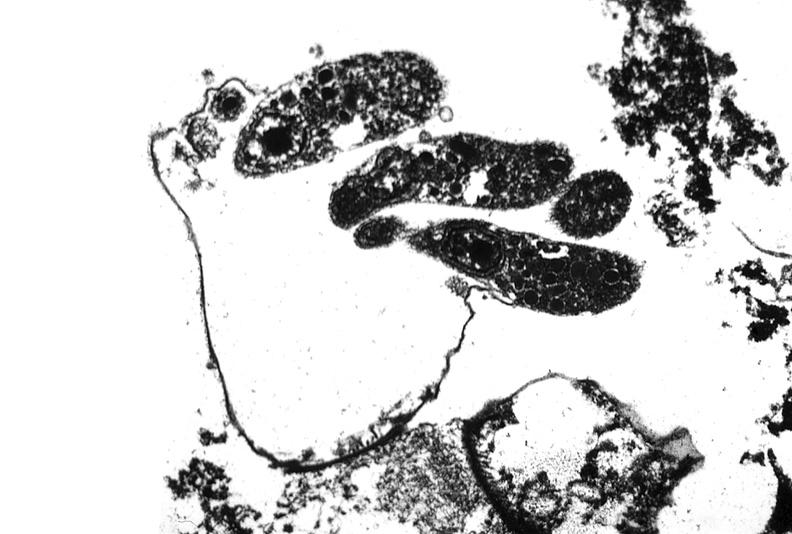what is present?
Answer the question using a single word or phrase. Gastrointestinal 